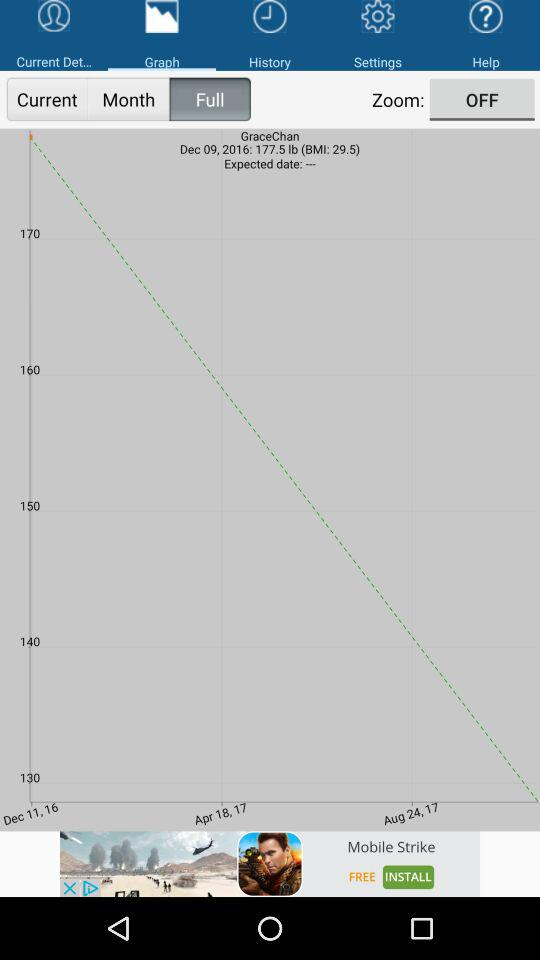What is the status of the "Zoom"? The status is "off". 